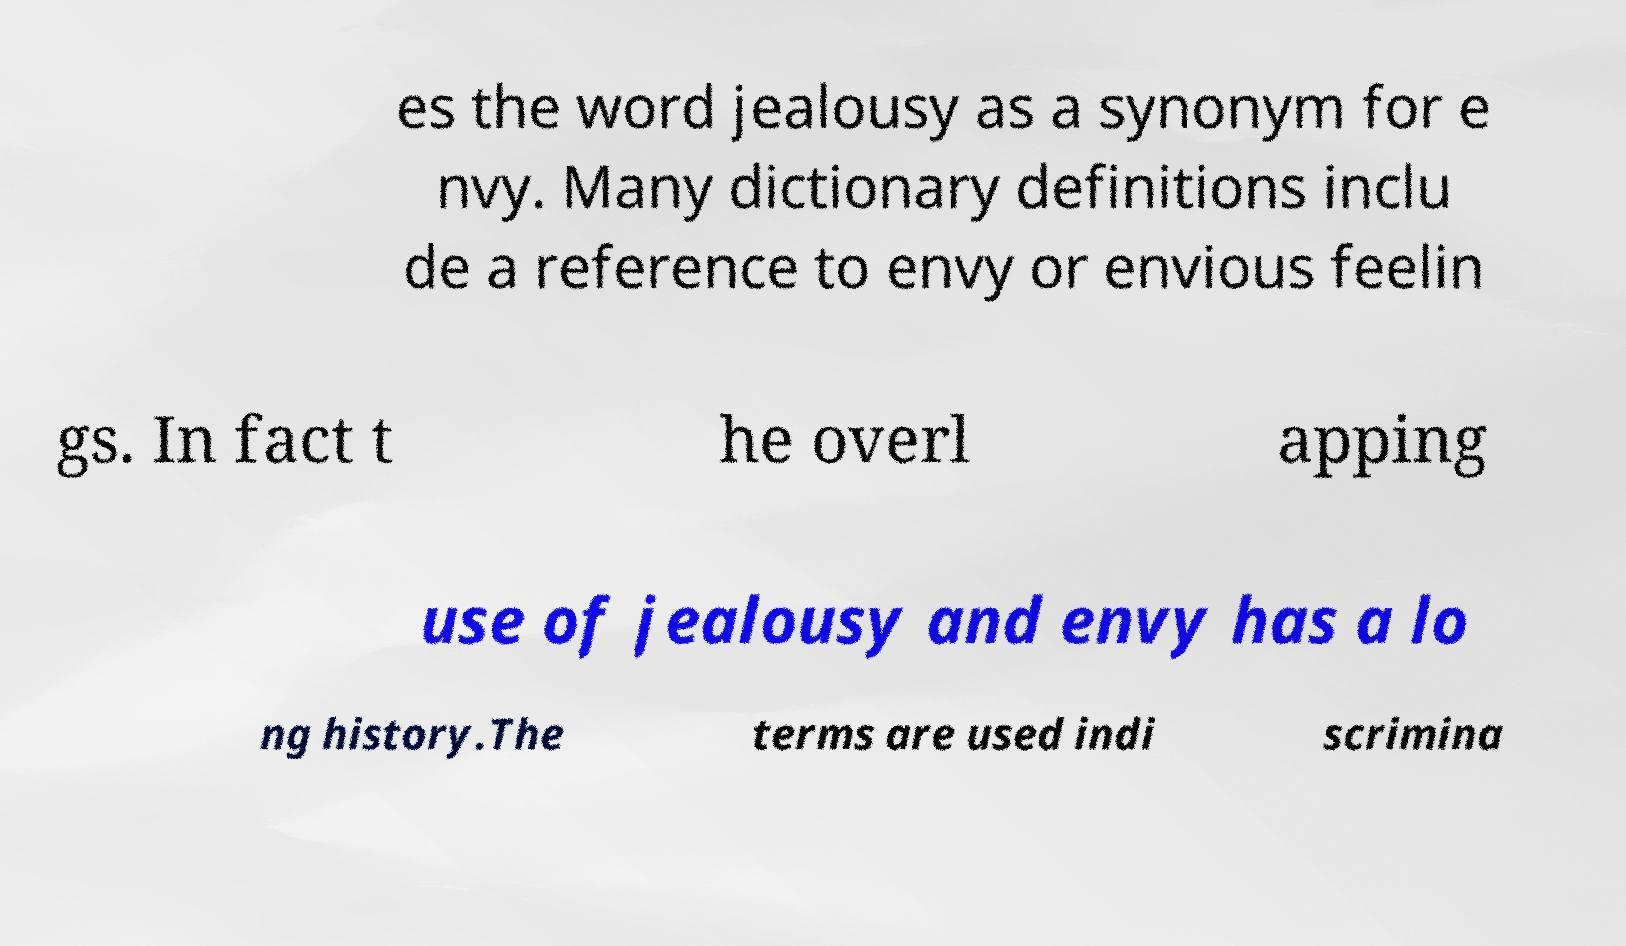Please read and relay the text visible in this image. What does it say? es the word jealousy as a synonym for e nvy. Many dictionary definitions inclu de a reference to envy or envious feelin gs. In fact t he overl apping use of jealousy and envy has a lo ng history.The terms are used indi scrimina 